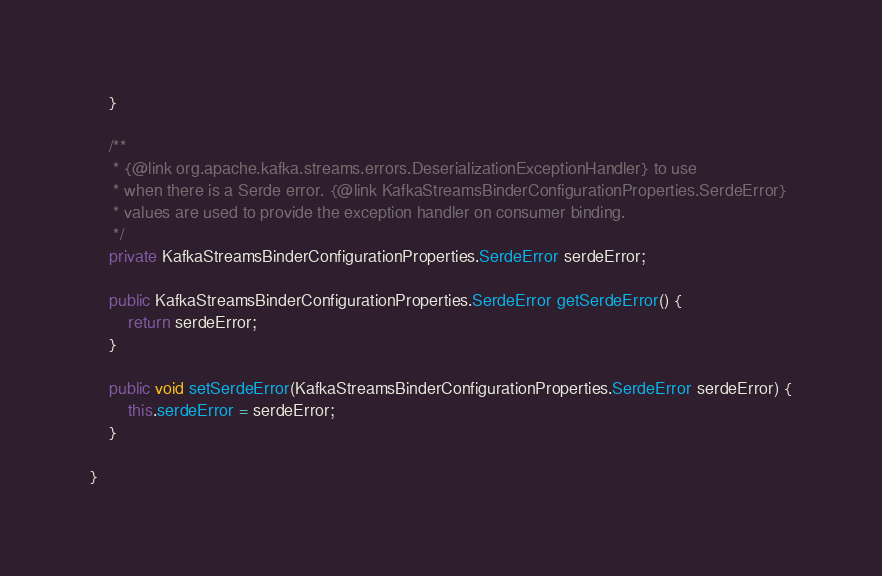Convert code to text. <code><loc_0><loc_0><loc_500><loc_500><_Java_>	}

	/**
	 * {@link org.apache.kafka.streams.errors.DeserializationExceptionHandler} to use
	 * when there is a Serde error. {@link KafkaStreamsBinderConfigurationProperties.SerdeError}
	 * values are used to provide the exception handler on consumer binding.
	 */
	private KafkaStreamsBinderConfigurationProperties.SerdeError serdeError;

	public KafkaStreamsBinderConfigurationProperties.SerdeError getSerdeError() {
		return serdeError;
	}

	public void setSerdeError(KafkaStreamsBinderConfigurationProperties.SerdeError serdeError) {
		this.serdeError = serdeError;
	}

}
</code> 